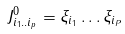Convert formula to latex. <formula><loc_0><loc_0><loc_500><loc_500>J _ { i _ { 1 } . . i _ { p } } ^ { 0 } = \xi _ { i _ { 1 } } \dots \xi _ { i _ { P } }</formula> 